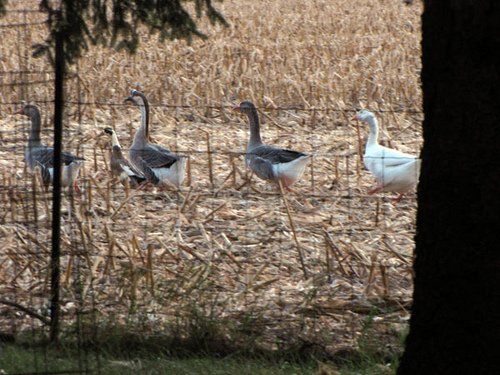<image>
Is the swan behind the tree? Yes. From this viewpoint, the swan is positioned behind the tree, with the tree partially or fully occluding the swan. 